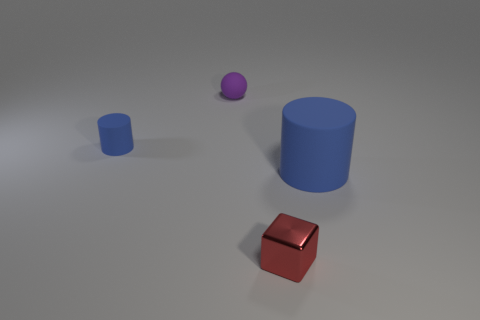Are there more large matte things that are in front of the purple thing than tiny cyan objects?
Your answer should be compact. Yes. What size is the blue cylinder that is made of the same material as the large blue thing?
Make the answer very short. Small. Are there any tiny cylinders that have the same color as the big cylinder?
Your response must be concise. Yes. How many objects are small blue objects or blue matte objects right of the block?
Ensure brevity in your answer.  2. Are there more large brown rubber cubes than small rubber spheres?
Make the answer very short. No. The rubber object that is the same color as the large cylinder is what size?
Offer a terse response. Small. Is there a large blue object made of the same material as the purple thing?
Provide a succinct answer. Yes. There is a thing that is both on the left side of the big matte cylinder and to the right of the small purple rubber ball; what shape is it?
Ensure brevity in your answer.  Cube. What number of other objects are the same shape as the shiny object?
Provide a succinct answer. 0. The red thing is what size?
Provide a short and direct response. Small. 